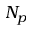Convert formula to latex. <formula><loc_0><loc_0><loc_500><loc_500>N _ { p }</formula> 